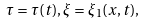<formula> <loc_0><loc_0><loc_500><loc_500>\tau = \tau ( t ) , \xi = \xi _ { 1 } ( x , t ) , \\</formula> 